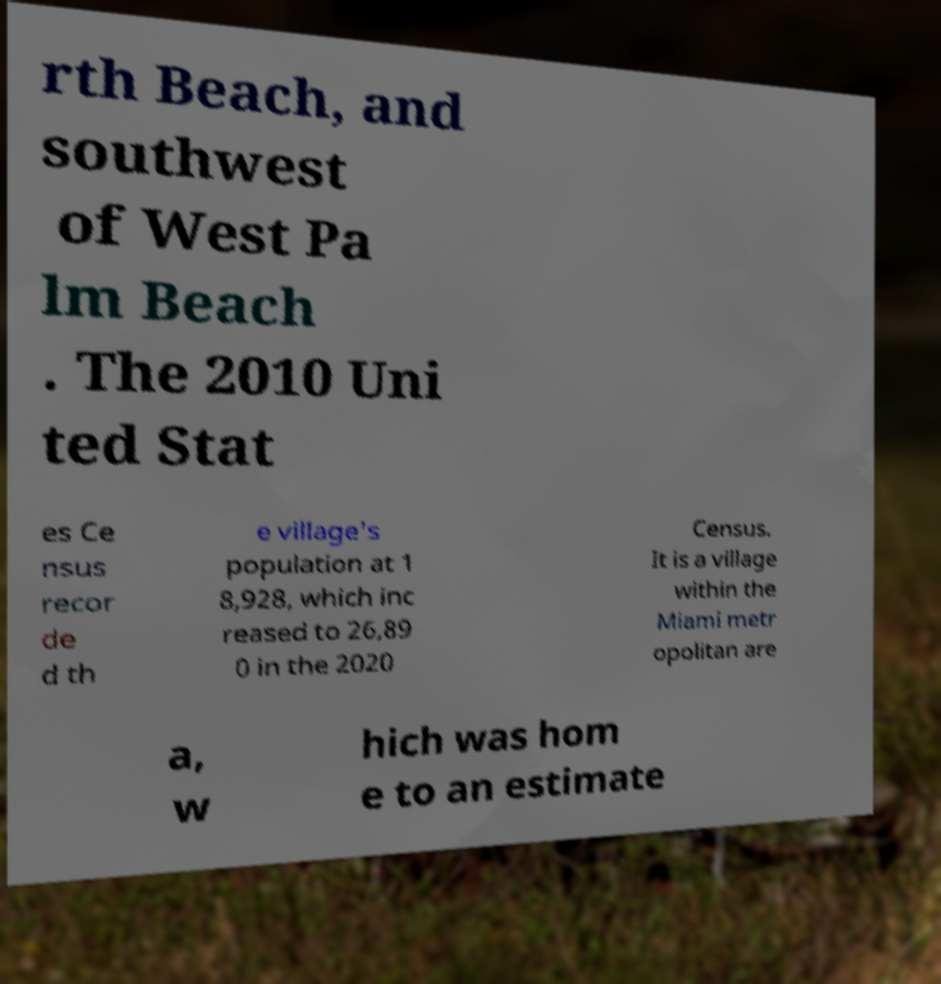For documentation purposes, I need the text within this image transcribed. Could you provide that? rth Beach, and southwest of West Pa lm Beach . The 2010 Uni ted Stat es Ce nsus recor de d th e village's population at 1 8,928, which inc reased to 26,89 0 in the 2020 Census. It is a village within the Miami metr opolitan are a, w hich was hom e to an estimate 